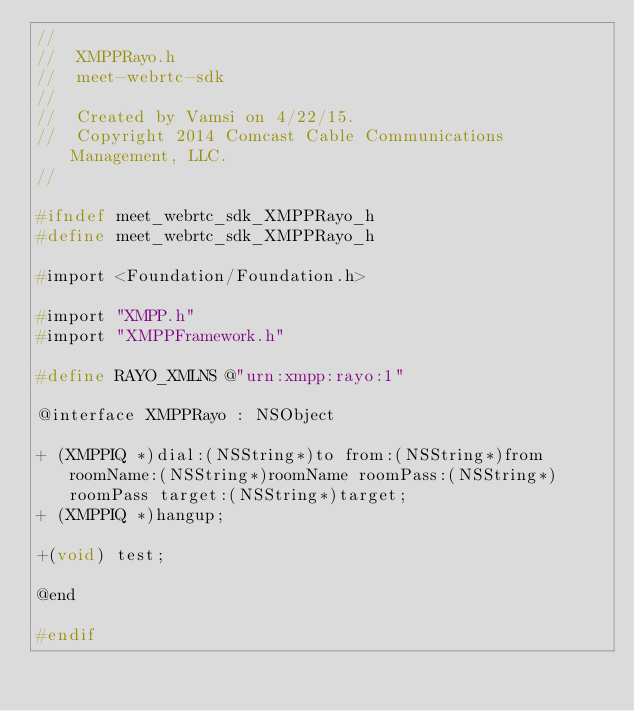<code> <loc_0><loc_0><loc_500><loc_500><_C_>//
//  XMPPRayo.h
//  meet-webrtc-sdk
//
//  Created by Vamsi on 4/22/15.
//  Copyright 2014 Comcast Cable Communications Management, LLC.
//

#ifndef meet_webrtc_sdk_XMPPRayo_h
#define meet_webrtc_sdk_XMPPRayo_h

#import <Foundation/Foundation.h>

#import "XMPP.h"
#import "XMPPFramework.h"

#define RAYO_XMLNS @"urn:xmpp:rayo:1"

@interface XMPPRayo : NSObject

+ (XMPPIQ *)dial:(NSString*)to from:(NSString*)from roomName:(NSString*)roomName roomPass:(NSString*)roomPass target:(NSString*)target;
+ (XMPPIQ *)hangup;

+(void) test;

@end

#endif
</code> 